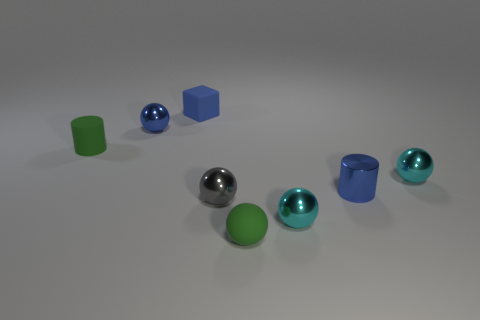Subtract all tiny cyan balls. How many balls are left? 3 Add 1 gray matte things. How many objects exist? 9 Subtract all gray spheres. How many spheres are left? 4 Subtract all balls. How many objects are left? 3 Subtract 1 cylinders. How many cylinders are left? 1 Subtract all purple balls. Subtract all cyan cylinders. How many balls are left? 5 Subtract all purple cylinders. How many gray balls are left? 1 Subtract all red cylinders. Subtract all blue blocks. How many objects are left? 7 Add 5 gray shiny spheres. How many gray shiny spheres are left? 6 Add 3 big cyan metallic balls. How many big cyan metallic balls exist? 3 